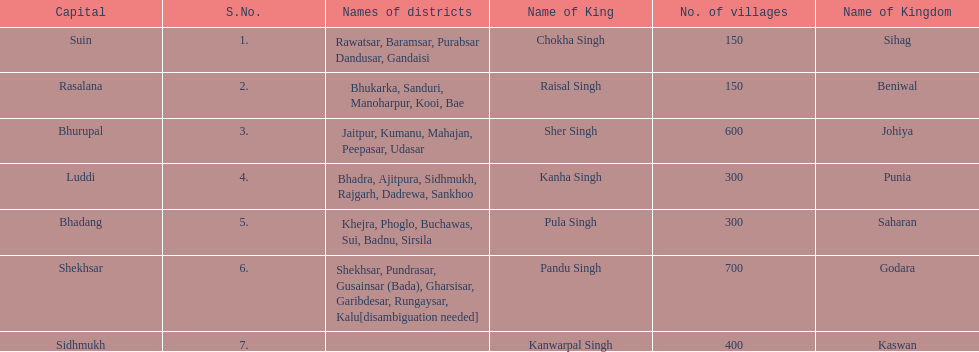What are all of the kingdoms? Sihag, Beniwal, Johiya, Punia, Saharan, Godara, Kaswan. How many villages do they contain? 150, 150, 600, 300, 300, 700, 400. How many are in godara? 700. Which kingdom comes next in highest amount of villages? Johiya. 